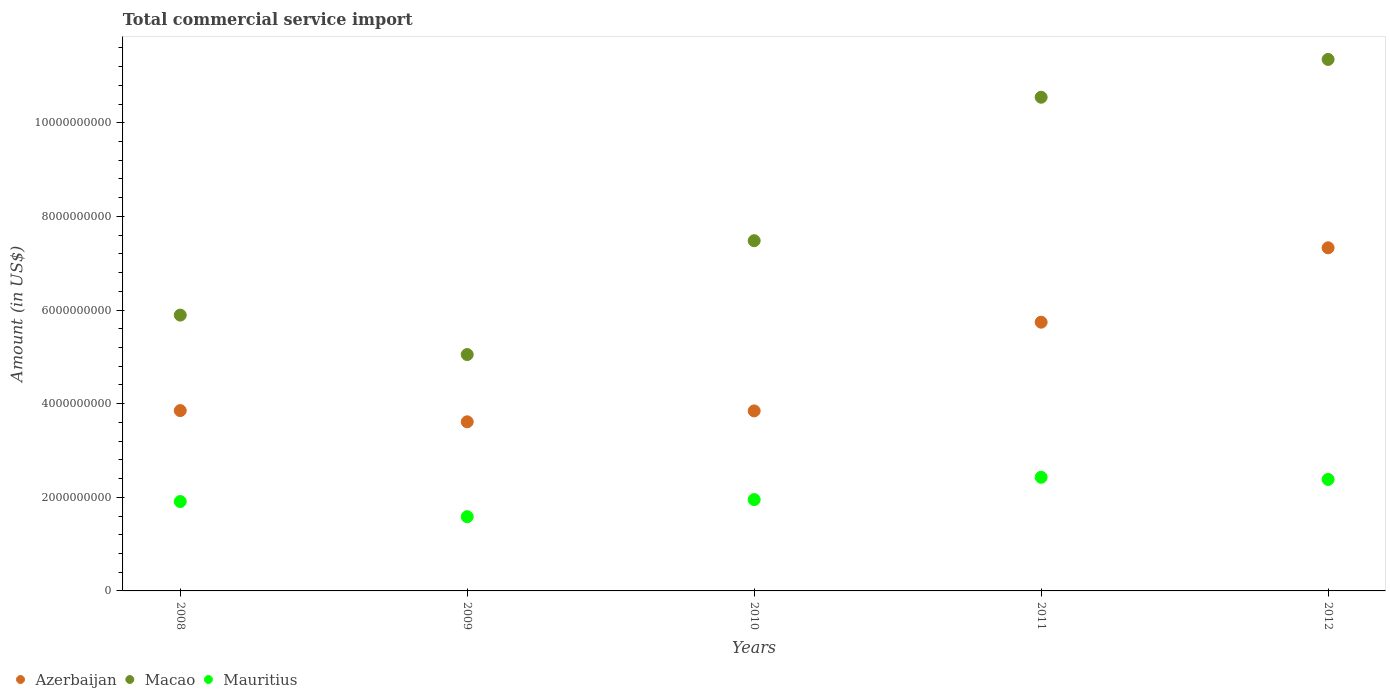What is the total commercial service import in Macao in 2012?
Offer a terse response. 1.14e+1. Across all years, what is the maximum total commercial service import in Azerbaijan?
Give a very brief answer. 7.33e+09. Across all years, what is the minimum total commercial service import in Mauritius?
Your answer should be very brief. 1.59e+09. In which year was the total commercial service import in Macao maximum?
Your answer should be compact. 2012. What is the total total commercial service import in Mauritius in the graph?
Offer a very short reply. 1.03e+1. What is the difference between the total commercial service import in Macao in 2011 and that in 2012?
Your answer should be very brief. -8.08e+08. What is the difference between the total commercial service import in Mauritius in 2011 and the total commercial service import in Azerbaijan in 2010?
Make the answer very short. -1.42e+09. What is the average total commercial service import in Mauritius per year?
Offer a very short reply. 2.05e+09. In the year 2009, what is the difference between the total commercial service import in Azerbaijan and total commercial service import in Mauritius?
Your answer should be very brief. 2.03e+09. In how many years, is the total commercial service import in Azerbaijan greater than 6000000000 US$?
Provide a succinct answer. 1. What is the ratio of the total commercial service import in Mauritius in 2010 to that in 2011?
Your response must be concise. 0.8. Is the difference between the total commercial service import in Azerbaijan in 2008 and 2009 greater than the difference between the total commercial service import in Mauritius in 2008 and 2009?
Offer a very short reply. No. What is the difference between the highest and the second highest total commercial service import in Mauritius?
Make the answer very short. 4.60e+07. What is the difference between the highest and the lowest total commercial service import in Macao?
Provide a succinct answer. 6.30e+09. Does the total commercial service import in Azerbaijan monotonically increase over the years?
Offer a very short reply. No. Is the total commercial service import in Azerbaijan strictly greater than the total commercial service import in Mauritius over the years?
Ensure brevity in your answer.  Yes. Is the total commercial service import in Azerbaijan strictly less than the total commercial service import in Macao over the years?
Ensure brevity in your answer.  Yes. How many years are there in the graph?
Your answer should be compact. 5. What is the difference between two consecutive major ticks on the Y-axis?
Make the answer very short. 2.00e+09. Does the graph contain any zero values?
Keep it short and to the point. No. Does the graph contain grids?
Your response must be concise. No. Where does the legend appear in the graph?
Your answer should be compact. Bottom left. How are the legend labels stacked?
Give a very brief answer. Horizontal. What is the title of the graph?
Offer a terse response. Total commercial service import. Does "Greenland" appear as one of the legend labels in the graph?
Provide a succinct answer. No. What is the label or title of the Y-axis?
Give a very brief answer. Amount (in US$). What is the Amount (in US$) in Azerbaijan in 2008?
Your answer should be very brief. 3.85e+09. What is the Amount (in US$) in Macao in 2008?
Offer a very short reply. 5.89e+09. What is the Amount (in US$) of Mauritius in 2008?
Offer a terse response. 1.91e+09. What is the Amount (in US$) in Azerbaijan in 2009?
Keep it short and to the point. 3.61e+09. What is the Amount (in US$) in Macao in 2009?
Offer a very short reply. 5.05e+09. What is the Amount (in US$) in Mauritius in 2009?
Your answer should be compact. 1.59e+09. What is the Amount (in US$) of Azerbaijan in 2010?
Make the answer very short. 3.85e+09. What is the Amount (in US$) in Macao in 2010?
Keep it short and to the point. 7.48e+09. What is the Amount (in US$) in Mauritius in 2010?
Make the answer very short. 1.95e+09. What is the Amount (in US$) of Azerbaijan in 2011?
Make the answer very short. 5.74e+09. What is the Amount (in US$) of Macao in 2011?
Offer a terse response. 1.05e+1. What is the Amount (in US$) in Mauritius in 2011?
Offer a very short reply. 2.43e+09. What is the Amount (in US$) in Azerbaijan in 2012?
Make the answer very short. 7.33e+09. What is the Amount (in US$) of Macao in 2012?
Offer a very short reply. 1.14e+1. What is the Amount (in US$) in Mauritius in 2012?
Your answer should be very brief. 2.38e+09. Across all years, what is the maximum Amount (in US$) of Azerbaijan?
Offer a terse response. 7.33e+09. Across all years, what is the maximum Amount (in US$) in Macao?
Keep it short and to the point. 1.14e+1. Across all years, what is the maximum Amount (in US$) of Mauritius?
Offer a very short reply. 2.43e+09. Across all years, what is the minimum Amount (in US$) in Azerbaijan?
Keep it short and to the point. 3.61e+09. Across all years, what is the minimum Amount (in US$) in Macao?
Make the answer very short. 5.05e+09. Across all years, what is the minimum Amount (in US$) in Mauritius?
Offer a terse response. 1.59e+09. What is the total Amount (in US$) of Azerbaijan in the graph?
Keep it short and to the point. 2.44e+1. What is the total Amount (in US$) of Macao in the graph?
Make the answer very short. 4.03e+1. What is the total Amount (in US$) of Mauritius in the graph?
Provide a short and direct response. 1.03e+1. What is the difference between the Amount (in US$) in Azerbaijan in 2008 and that in 2009?
Provide a succinct answer. 2.40e+08. What is the difference between the Amount (in US$) of Macao in 2008 and that in 2009?
Offer a very short reply. 8.43e+08. What is the difference between the Amount (in US$) of Mauritius in 2008 and that in 2009?
Your response must be concise. 3.24e+08. What is the difference between the Amount (in US$) of Azerbaijan in 2008 and that in 2010?
Your response must be concise. 6.83e+06. What is the difference between the Amount (in US$) in Macao in 2008 and that in 2010?
Keep it short and to the point. -1.59e+09. What is the difference between the Amount (in US$) in Mauritius in 2008 and that in 2010?
Your answer should be very brief. -4.12e+07. What is the difference between the Amount (in US$) of Azerbaijan in 2008 and that in 2011?
Provide a succinct answer. -1.89e+09. What is the difference between the Amount (in US$) of Macao in 2008 and that in 2011?
Provide a short and direct response. -4.65e+09. What is the difference between the Amount (in US$) of Mauritius in 2008 and that in 2011?
Offer a very short reply. -5.18e+08. What is the difference between the Amount (in US$) in Azerbaijan in 2008 and that in 2012?
Provide a succinct answer. -3.48e+09. What is the difference between the Amount (in US$) of Macao in 2008 and that in 2012?
Provide a short and direct response. -5.46e+09. What is the difference between the Amount (in US$) of Mauritius in 2008 and that in 2012?
Give a very brief answer. -4.72e+08. What is the difference between the Amount (in US$) of Azerbaijan in 2009 and that in 2010?
Offer a very short reply. -2.33e+08. What is the difference between the Amount (in US$) of Macao in 2009 and that in 2010?
Provide a succinct answer. -2.43e+09. What is the difference between the Amount (in US$) of Mauritius in 2009 and that in 2010?
Your answer should be very brief. -3.65e+08. What is the difference between the Amount (in US$) in Azerbaijan in 2009 and that in 2011?
Offer a very short reply. -2.13e+09. What is the difference between the Amount (in US$) in Macao in 2009 and that in 2011?
Give a very brief answer. -5.50e+09. What is the difference between the Amount (in US$) of Mauritius in 2009 and that in 2011?
Your answer should be very brief. -8.42e+08. What is the difference between the Amount (in US$) in Azerbaijan in 2009 and that in 2012?
Provide a succinct answer. -3.72e+09. What is the difference between the Amount (in US$) of Macao in 2009 and that in 2012?
Keep it short and to the point. -6.30e+09. What is the difference between the Amount (in US$) of Mauritius in 2009 and that in 2012?
Give a very brief answer. -7.96e+08. What is the difference between the Amount (in US$) of Azerbaijan in 2010 and that in 2011?
Give a very brief answer. -1.90e+09. What is the difference between the Amount (in US$) in Macao in 2010 and that in 2011?
Provide a short and direct response. -3.06e+09. What is the difference between the Amount (in US$) of Mauritius in 2010 and that in 2011?
Your answer should be very brief. -4.77e+08. What is the difference between the Amount (in US$) of Azerbaijan in 2010 and that in 2012?
Your response must be concise. -3.48e+09. What is the difference between the Amount (in US$) in Macao in 2010 and that in 2012?
Give a very brief answer. -3.87e+09. What is the difference between the Amount (in US$) of Mauritius in 2010 and that in 2012?
Your answer should be very brief. -4.31e+08. What is the difference between the Amount (in US$) in Azerbaijan in 2011 and that in 2012?
Offer a terse response. -1.59e+09. What is the difference between the Amount (in US$) of Macao in 2011 and that in 2012?
Offer a very short reply. -8.08e+08. What is the difference between the Amount (in US$) in Mauritius in 2011 and that in 2012?
Your answer should be very brief. 4.60e+07. What is the difference between the Amount (in US$) of Azerbaijan in 2008 and the Amount (in US$) of Macao in 2009?
Your response must be concise. -1.20e+09. What is the difference between the Amount (in US$) of Azerbaijan in 2008 and the Amount (in US$) of Mauritius in 2009?
Offer a very short reply. 2.27e+09. What is the difference between the Amount (in US$) in Macao in 2008 and the Amount (in US$) in Mauritius in 2009?
Your response must be concise. 4.31e+09. What is the difference between the Amount (in US$) in Azerbaijan in 2008 and the Amount (in US$) in Macao in 2010?
Your answer should be compact. -3.63e+09. What is the difference between the Amount (in US$) in Azerbaijan in 2008 and the Amount (in US$) in Mauritius in 2010?
Your answer should be very brief. 1.90e+09. What is the difference between the Amount (in US$) in Macao in 2008 and the Amount (in US$) in Mauritius in 2010?
Give a very brief answer. 3.94e+09. What is the difference between the Amount (in US$) of Azerbaijan in 2008 and the Amount (in US$) of Macao in 2011?
Offer a terse response. -6.69e+09. What is the difference between the Amount (in US$) of Azerbaijan in 2008 and the Amount (in US$) of Mauritius in 2011?
Provide a succinct answer. 1.42e+09. What is the difference between the Amount (in US$) of Macao in 2008 and the Amount (in US$) of Mauritius in 2011?
Provide a short and direct response. 3.46e+09. What is the difference between the Amount (in US$) of Azerbaijan in 2008 and the Amount (in US$) of Macao in 2012?
Ensure brevity in your answer.  -7.50e+09. What is the difference between the Amount (in US$) of Azerbaijan in 2008 and the Amount (in US$) of Mauritius in 2012?
Your response must be concise. 1.47e+09. What is the difference between the Amount (in US$) of Macao in 2008 and the Amount (in US$) of Mauritius in 2012?
Offer a terse response. 3.51e+09. What is the difference between the Amount (in US$) of Azerbaijan in 2009 and the Amount (in US$) of Macao in 2010?
Provide a short and direct response. -3.87e+09. What is the difference between the Amount (in US$) in Azerbaijan in 2009 and the Amount (in US$) in Mauritius in 2010?
Your response must be concise. 1.66e+09. What is the difference between the Amount (in US$) in Macao in 2009 and the Amount (in US$) in Mauritius in 2010?
Give a very brief answer. 3.10e+09. What is the difference between the Amount (in US$) of Azerbaijan in 2009 and the Amount (in US$) of Macao in 2011?
Your answer should be compact. -6.93e+09. What is the difference between the Amount (in US$) in Azerbaijan in 2009 and the Amount (in US$) in Mauritius in 2011?
Offer a terse response. 1.19e+09. What is the difference between the Amount (in US$) of Macao in 2009 and the Amount (in US$) of Mauritius in 2011?
Your response must be concise. 2.62e+09. What is the difference between the Amount (in US$) of Azerbaijan in 2009 and the Amount (in US$) of Macao in 2012?
Give a very brief answer. -7.74e+09. What is the difference between the Amount (in US$) in Azerbaijan in 2009 and the Amount (in US$) in Mauritius in 2012?
Your answer should be compact. 1.23e+09. What is the difference between the Amount (in US$) of Macao in 2009 and the Amount (in US$) of Mauritius in 2012?
Your answer should be compact. 2.67e+09. What is the difference between the Amount (in US$) of Azerbaijan in 2010 and the Amount (in US$) of Macao in 2011?
Ensure brevity in your answer.  -6.70e+09. What is the difference between the Amount (in US$) of Azerbaijan in 2010 and the Amount (in US$) of Mauritius in 2011?
Keep it short and to the point. 1.42e+09. What is the difference between the Amount (in US$) in Macao in 2010 and the Amount (in US$) in Mauritius in 2011?
Provide a short and direct response. 5.05e+09. What is the difference between the Amount (in US$) of Azerbaijan in 2010 and the Amount (in US$) of Macao in 2012?
Your response must be concise. -7.51e+09. What is the difference between the Amount (in US$) in Azerbaijan in 2010 and the Amount (in US$) in Mauritius in 2012?
Provide a succinct answer. 1.46e+09. What is the difference between the Amount (in US$) in Macao in 2010 and the Amount (in US$) in Mauritius in 2012?
Offer a very short reply. 5.10e+09. What is the difference between the Amount (in US$) in Azerbaijan in 2011 and the Amount (in US$) in Macao in 2012?
Give a very brief answer. -5.61e+09. What is the difference between the Amount (in US$) in Azerbaijan in 2011 and the Amount (in US$) in Mauritius in 2012?
Provide a succinct answer. 3.36e+09. What is the difference between the Amount (in US$) in Macao in 2011 and the Amount (in US$) in Mauritius in 2012?
Your answer should be compact. 8.16e+09. What is the average Amount (in US$) in Azerbaijan per year?
Provide a succinct answer. 4.88e+09. What is the average Amount (in US$) in Macao per year?
Your answer should be very brief. 8.06e+09. What is the average Amount (in US$) of Mauritius per year?
Your response must be concise. 2.05e+09. In the year 2008, what is the difference between the Amount (in US$) of Azerbaijan and Amount (in US$) of Macao?
Your answer should be very brief. -2.04e+09. In the year 2008, what is the difference between the Amount (in US$) of Azerbaijan and Amount (in US$) of Mauritius?
Provide a succinct answer. 1.94e+09. In the year 2008, what is the difference between the Amount (in US$) in Macao and Amount (in US$) in Mauritius?
Make the answer very short. 3.98e+09. In the year 2009, what is the difference between the Amount (in US$) of Azerbaijan and Amount (in US$) of Macao?
Give a very brief answer. -1.44e+09. In the year 2009, what is the difference between the Amount (in US$) in Azerbaijan and Amount (in US$) in Mauritius?
Give a very brief answer. 2.03e+09. In the year 2009, what is the difference between the Amount (in US$) of Macao and Amount (in US$) of Mauritius?
Make the answer very short. 3.46e+09. In the year 2010, what is the difference between the Amount (in US$) of Azerbaijan and Amount (in US$) of Macao?
Make the answer very short. -3.64e+09. In the year 2010, what is the difference between the Amount (in US$) of Azerbaijan and Amount (in US$) of Mauritius?
Your answer should be compact. 1.89e+09. In the year 2010, what is the difference between the Amount (in US$) in Macao and Amount (in US$) in Mauritius?
Keep it short and to the point. 5.53e+09. In the year 2011, what is the difference between the Amount (in US$) of Azerbaijan and Amount (in US$) of Macao?
Your answer should be very brief. -4.81e+09. In the year 2011, what is the difference between the Amount (in US$) of Azerbaijan and Amount (in US$) of Mauritius?
Make the answer very short. 3.31e+09. In the year 2011, what is the difference between the Amount (in US$) in Macao and Amount (in US$) in Mauritius?
Ensure brevity in your answer.  8.12e+09. In the year 2012, what is the difference between the Amount (in US$) in Azerbaijan and Amount (in US$) in Macao?
Your response must be concise. -4.02e+09. In the year 2012, what is the difference between the Amount (in US$) in Azerbaijan and Amount (in US$) in Mauritius?
Give a very brief answer. 4.95e+09. In the year 2012, what is the difference between the Amount (in US$) of Macao and Amount (in US$) of Mauritius?
Offer a terse response. 8.97e+09. What is the ratio of the Amount (in US$) of Azerbaijan in 2008 to that in 2009?
Keep it short and to the point. 1.07. What is the ratio of the Amount (in US$) of Macao in 2008 to that in 2009?
Offer a very short reply. 1.17. What is the ratio of the Amount (in US$) of Mauritius in 2008 to that in 2009?
Give a very brief answer. 1.2. What is the ratio of the Amount (in US$) in Macao in 2008 to that in 2010?
Offer a terse response. 0.79. What is the ratio of the Amount (in US$) in Mauritius in 2008 to that in 2010?
Keep it short and to the point. 0.98. What is the ratio of the Amount (in US$) in Azerbaijan in 2008 to that in 2011?
Keep it short and to the point. 0.67. What is the ratio of the Amount (in US$) of Macao in 2008 to that in 2011?
Your answer should be compact. 0.56. What is the ratio of the Amount (in US$) of Mauritius in 2008 to that in 2011?
Offer a terse response. 0.79. What is the ratio of the Amount (in US$) of Azerbaijan in 2008 to that in 2012?
Your answer should be compact. 0.53. What is the ratio of the Amount (in US$) of Macao in 2008 to that in 2012?
Make the answer very short. 0.52. What is the ratio of the Amount (in US$) in Mauritius in 2008 to that in 2012?
Provide a succinct answer. 0.8. What is the ratio of the Amount (in US$) in Azerbaijan in 2009 to that in 2010?
Give a very brief answer. 0.94. What is the ratio of the Amount (in US$) of Macao in 2009 to that in 2010?
Your answer should be very brief. 0.68. What is the ratio of the Amount (in US$) in Mauritius in 2009 to that in 2010?
Offer a terse response. 0.81. What is the ratio of the Amount (in US$) of Azerbaijan in 2009 to that in 2011?
Your response must be concise. 0.63. What is the ratio of the Amount (in US$) of Macao in 2009 to that in 2011?
Your answer should be compact. 0.48. What is the ratio of the Amount (in US$) in Mauritius in 2009 to that in 2011?
Give a very brief answer. 0.65. What is the ratio of the Amount (in US$) of Azerbaijan in 2009 to that in 2012?
Offer a terse response. 0.49. What is the ratio of the Amount (in US$) in Macao in 2009 to that in 2012?
Ensure brevity in your answer.  0.44. What is the ratio of the Amount (in US$) of Mauritius in 2009 to that in 2012?
Give a very brief answer. 0.67. What is the ratio of the Amount (in US$) in Azerbaijan in 2010 to that in 2011?
Your answer should be very brief. 0.67. What is the ratio of the Amount (in US$) of Macao in 2010 to that in 2011?
Make the answer very short. 0.71. What is the ratio of the Amount (in US$) of Mauritius in 2010 to that in 2011?
Your answer should be compact. 0.8. What is the ratio of the Amount (in US$) in Azerbaijan in 2010 to that in 2012?
Your answer should be compact. 0.52. What is the ratio of the Amount (in US$) in Macao in 2010 to that in 2012?
Provide a succinct answer. 0.66. What is the ratio of the Amount (in US$) of Mauritius in 2010 to that in 2012?
Provide a short and direct response. 0.82. What is the ratio of the Amount (in US$) of Azerbaijan in 2011 to that in 2012?
Provide a succinct answer. 0.78. What is the ratio of the Amount (in US$) of Macao in 2011 to that in 2012?
Your response must be concise. 0.93. What is the ratio of the Amount (in US$) of Mauritius in 2011 to that in 2012?
Provide a succinct answer. 1.02. What is the difference between the highest and the second highest Amount (in US$) in Azerbaijan?
Provide a short and direct response. 1.59e+09. What is the difference between the highest and the second highest Amount (in US$) in Macao?
Your answer should be very brief. 8.08e+08. What is the difference between the highest and the second highest Amount (in US$) in Mauritius?
Offer a terse response. 4.60e+07. What is the difference between the highest and the lowest Amount (in US$) of Azerbaijan?
Provide a succinct answer. 3.72e+09. What is the difference between the highest and the lowest Amount (in US$) of Macao?
Keep it short and to the point. 6.30e+09. What is the difference between the highest and the lowest Amount (in US$) in Mauritius?
Provide a short and direct response. 8.42e+08. 